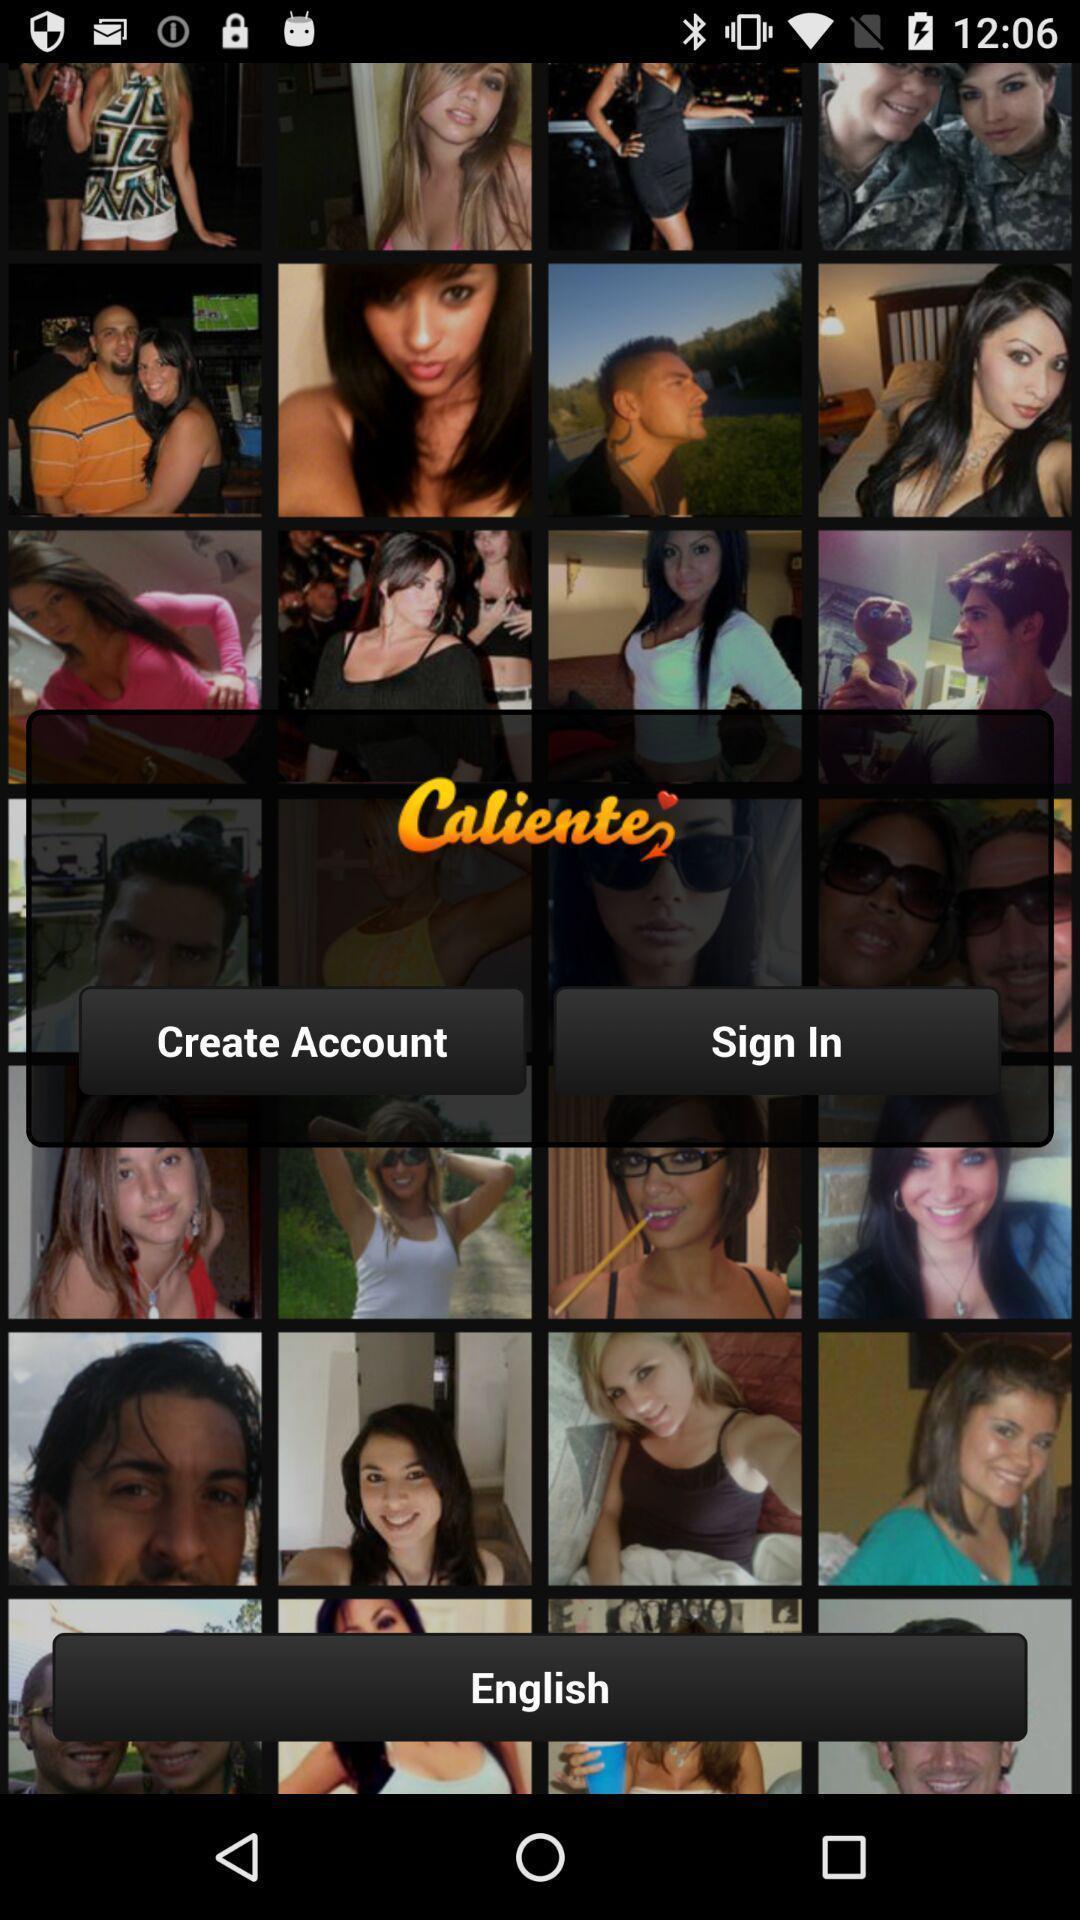Give me a summary of this screen capture. Welcome page displaying to create an account. 